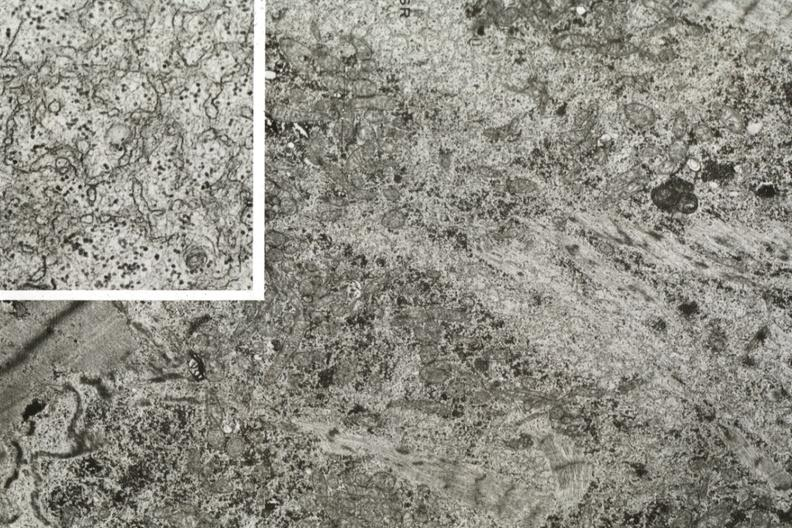what does this image show?
Answer the question using a single word or phrase. Electron micrographs demonstrating marked loss of myofibrils in fiber and inset with dilated sarcoplasmic reticulum 